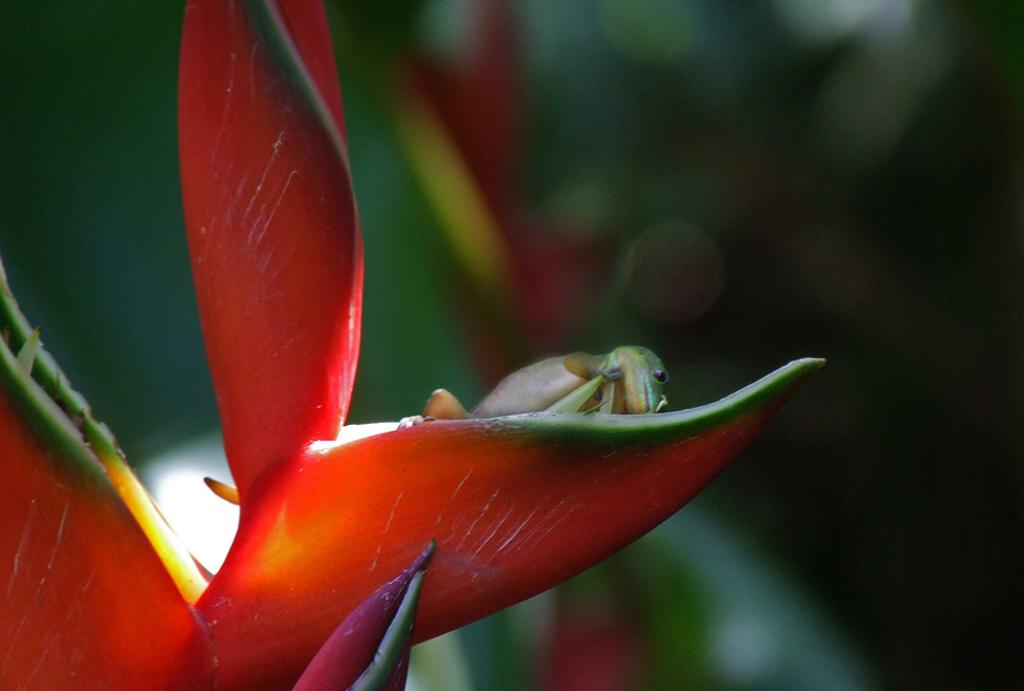What type of animal is in the image? There is a lizard in the image. Where is the lizard located? The lizard is on a flower. Can you describe the background of the image? The background of the image is blurred. How many dimes can be seen on the lizard's back in the image? There are no dimes present in the image; it features a lizard on a flower. What type of woolly animal is visible in the image? There is no woolly animal, such as a sheep, present in the image. 